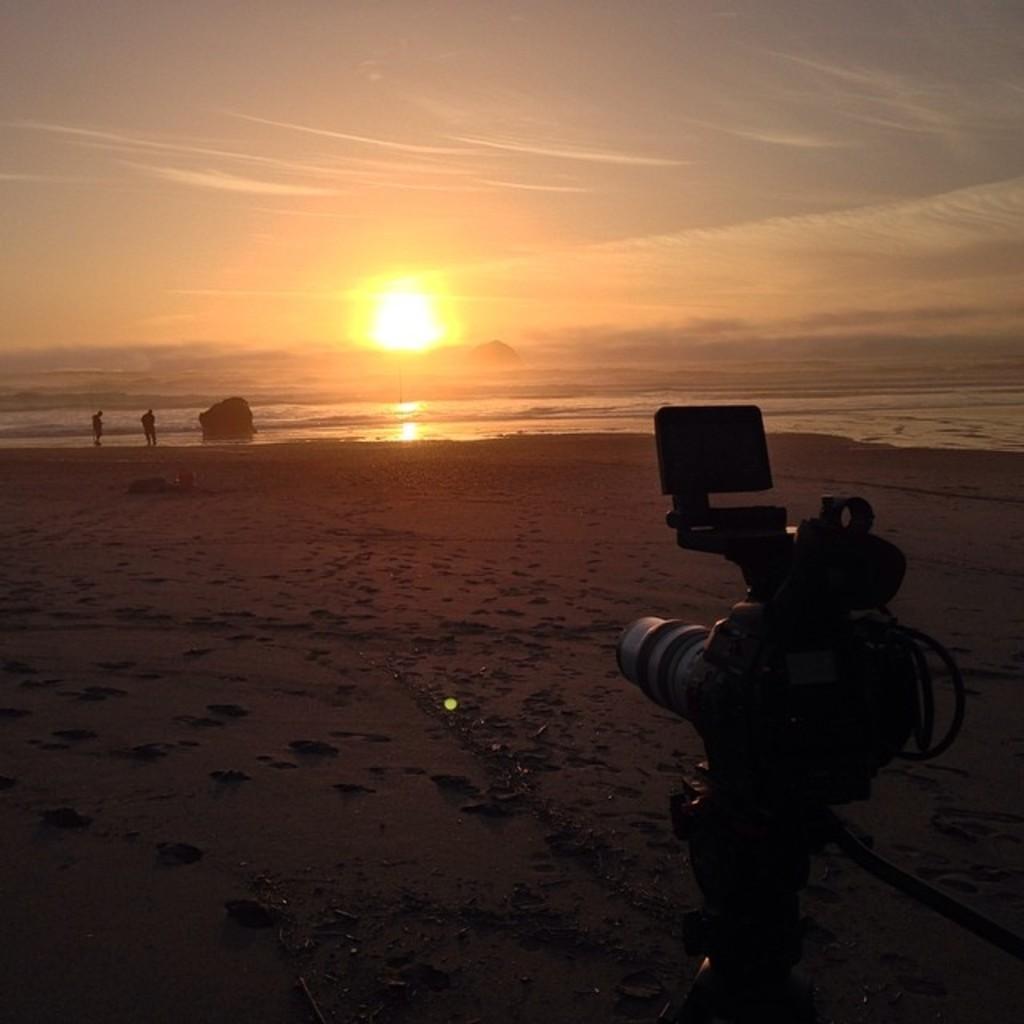Describe this image in one or two sentences. In the image there is a camera in the foreground and behind the camera there is a sand surface, in the background there is a sea and there are two people standing in front of the sea. 